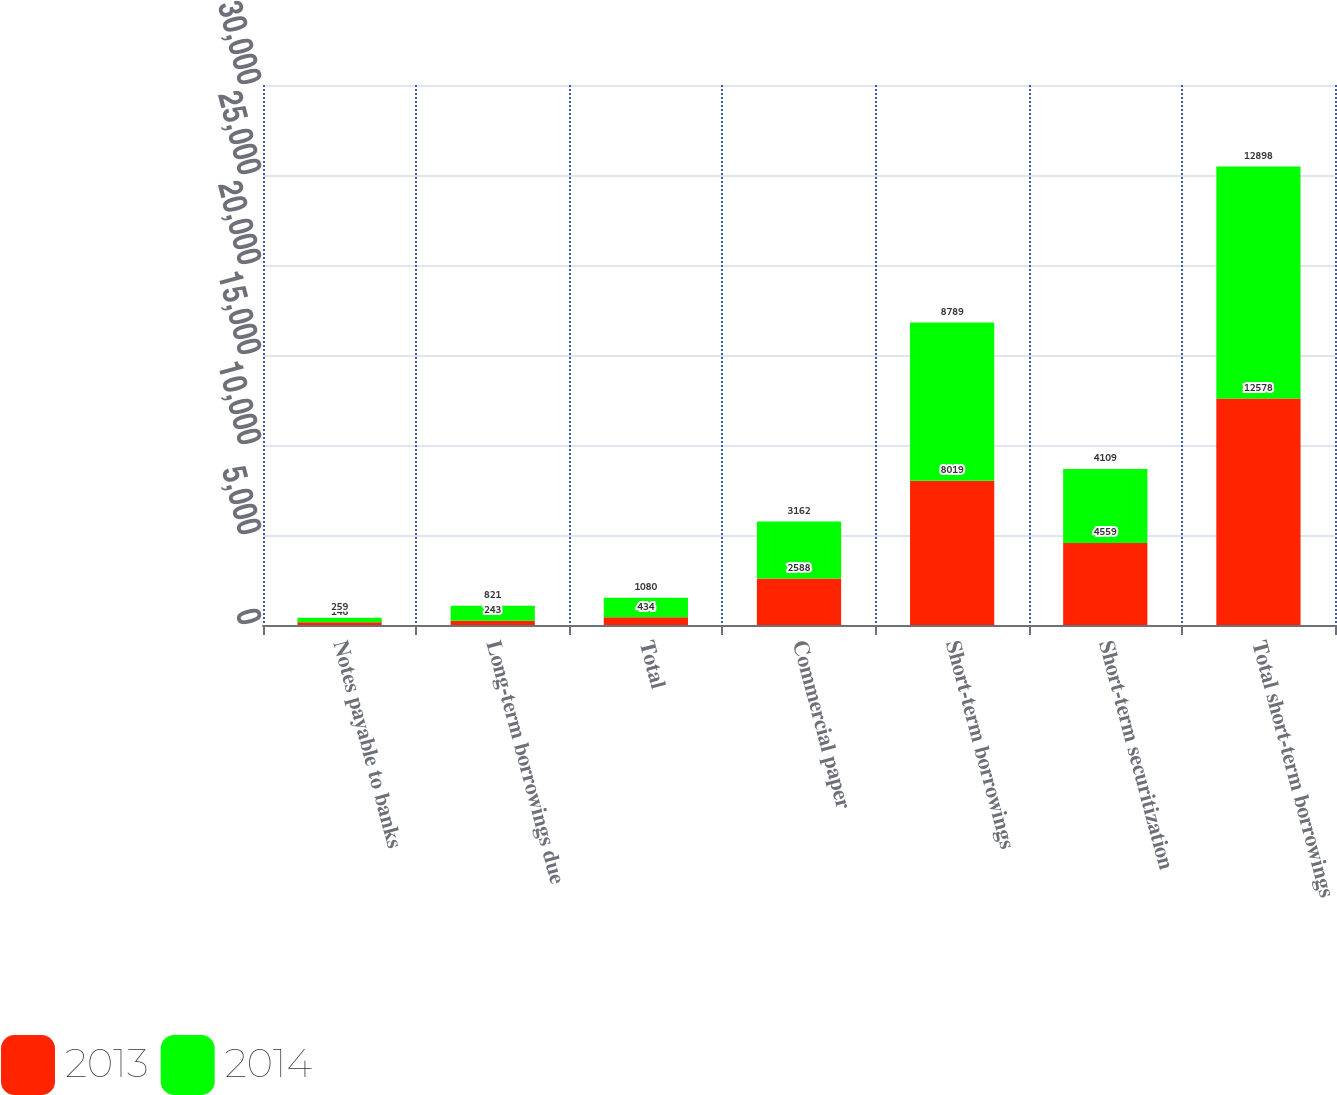Convert chart. <chart><loc_0><loc_0><loc_500><loc_500><stacked_bar_chart><ecel><fcel>Notes payable to banks<fcel>Long-term borrowings due<fcel>Total<fcel>Commercial paper<fcel>Short-term borrowings<fcel>Short-term securitization<fcel>Total short-term borrowings<nl><fcel>2013<fcel>146<fcel>243<fcel>434<fcel>2588<fcel>8019<fcel>4559<fcel>12578<nl><fcel>2014<fcel>259<fcel>821<fcel>1080<fcel>3162<fcel>8789<fcel>4109<fcel>12898<nl></chart> 